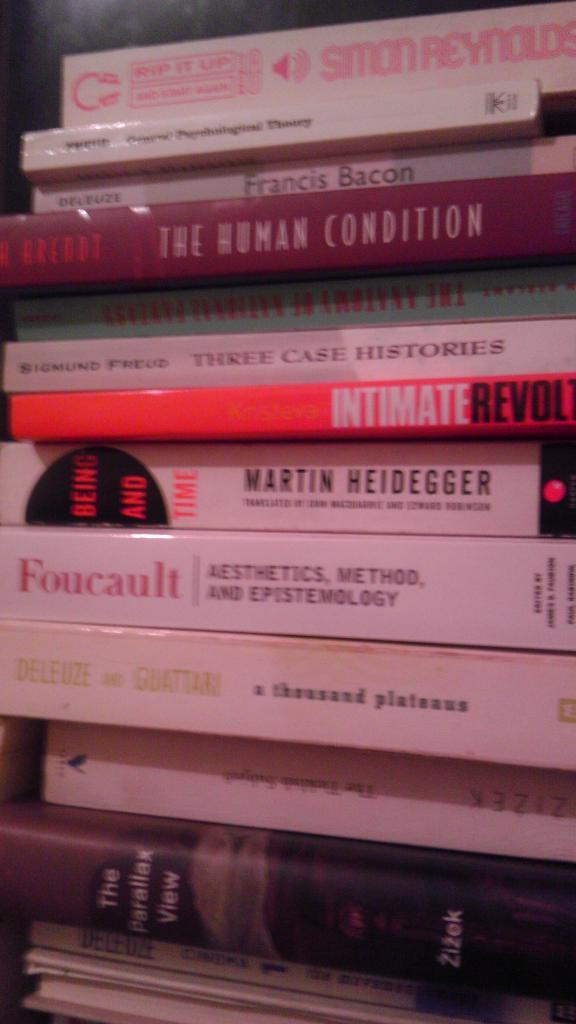Provide a one-sentence caption for the provided image. The fourth book down in the stack is titled, "The Human Condition.". 